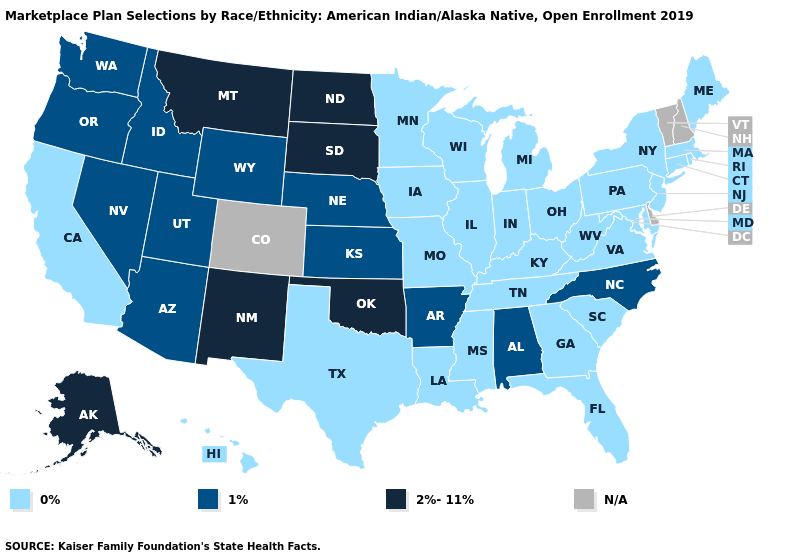Does North Carolina have the highest value in the USA?
Give a very brief answer. No. Name the states that have a value in the range 2%-11%?
Concise answer only. Alaska, Montana, New Mexico, North Dakota, Oklahoma, South Dakota. Name the states that have a value in the range 0%?
Quick response, please. California, Connecticut, Florida, Georgia, Hawaii, Illinois, Indiana, Iowa, Kentucky, Louisiana, Maine, Maryland, Massachusetts, Michigan, Minnesota, Mississippi, Missouri, New Jersey, New York, Ohio, Pennsylvania, Rhode Island, South Carolina, Tennessee, Texas, Virginia, West Virginia, Wisconsin. Which states have the highest value in the USA?
Concise answer only. Alaska, Montana, New Mexico, North Dakota, Oklahoma, South Dakota. Among the states that border Massachusetts , which have the lowest value?
Be succinct. Connecticut, New York, Rhode Island. Which states hav the highest value in the West?
Short answer required. Alaska, Montana, New Mexico. Which states hav the highest value in the MidWest?
Write a very short answer. North Dakota, South Dakota. What is the value of Pennsylvania?
Short answer required. 0%. What is the highest value in the Northeast ?
Be succinct. 0%. Among the states that border Idaho , which have the lowest value?
Answer briefly. Nevada, Oregon, Utah, Washington, Wyoming. Does Utah have the highest value in the USA?
Give a very brief answer. No. What is the value of Texas?
Be succinct. 0%. How many symbols are there in the legend?
Concise answer only. 4. What is the value of New Hampshire?
Give a very brief answer. N/A. 